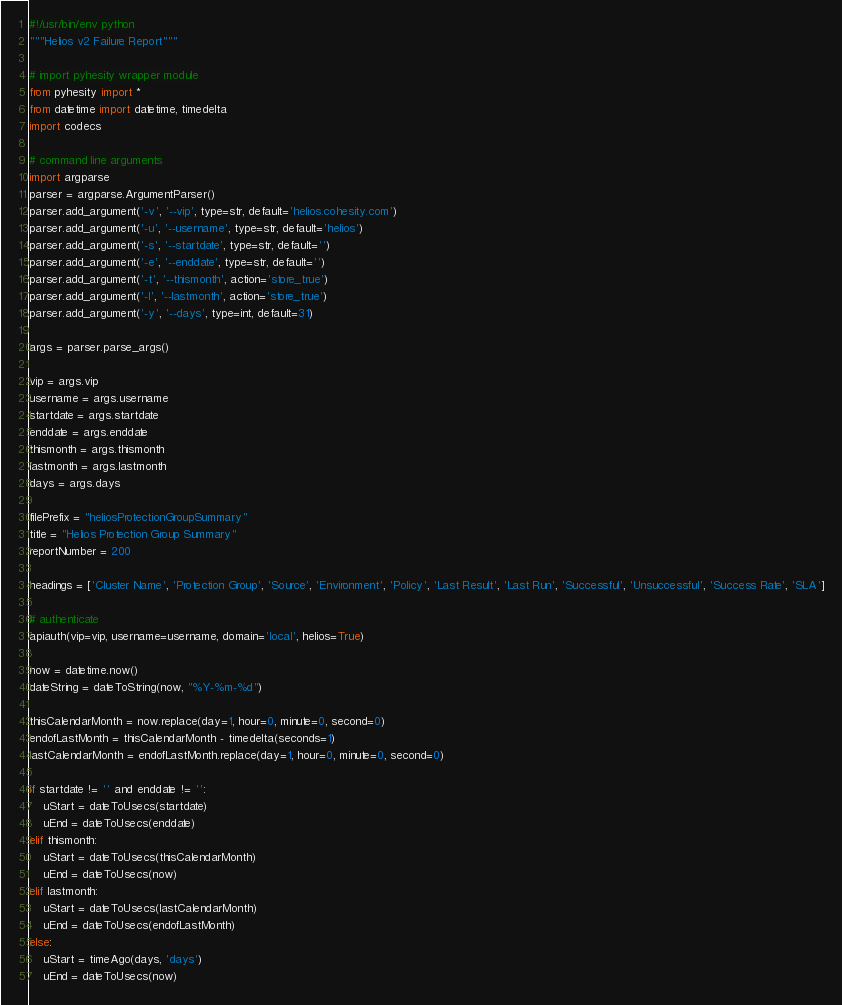<code> <loc_0><loc_0><loc_500><loc_500><_Python_>#!/usr/bin/env python
"""Helios v2 Failure Report"""

# import pyhesity wrapper module
from pyhesity import *
from datetime import datetime, timedelta
import codecs

# command line arguments
import argparse
parser = argparse.ArgumentParser()
parser.add_argument('-v', '--vip', type=str, default='helios.cohesity.com')
parser.add_argument('-u', '--username', type=str, default='helios')
parser.add_argument('-s', '--startdate', type=str, default='')
parser.add_argument('-e', '--enddate', type=str, default='')
parser.add_argument('-t', '--thismonth', action='store_true')
parser.add_argument('-l', '--lastmonth', action='store_true')
parser.add_argument('-y', '--days', type=int, default=31)

args = parser.parse_args()

vip = args.vip
username = args.username
startdate = args.startdate
enddate = args.enddate
thismonth = args.thismonth
lastmonth = args.lastmonth
days = args.days

filePrefix = "heliosProtectionGroupSummary"
title = "Helios Protection Group Summary"
reportNumber = 200

headings = ['Cluster Name', 'Protection Group', 'Source', 'Environment', 'Policy', 'Last Result', 'Last Run', 'Successful', 'Unsuccessful', 'Success Rate', 'SLA']

# authenticate
apiauth(vip=vip, username=username, domain='local', helios=True)

now = datetime.now()
dateString = dateToString(now, "%Y-%m-%d")

thisCalendarMonth = now.replace(day=1, hour=0, minute=0, second=0)
endofLastMonth = thisCalendarMonth - timedelta(seconds=1)
lastCalendarMonth = endofLastMonth.replace(day=1, hour=0, minute=0, second=0)

if startdate != '' and enddate != '':
    uStart = dateToUsecs(startdate)
    uEnd = dateToUsecs(enddate)
elif thismonth:
    uStart = dateToUsecs(thisCalendarMonth)
    uEnd = dateToUsecs(now)
elif lastmonth:
    uStart = dateToUsecs(lastCalendarMonth)
    uEnd = dateToUsecs(endofLastMonth)
else:
    uStart = timeAgo(days, 'days')
    uEnd = dateToUsecs(now)
</code> 